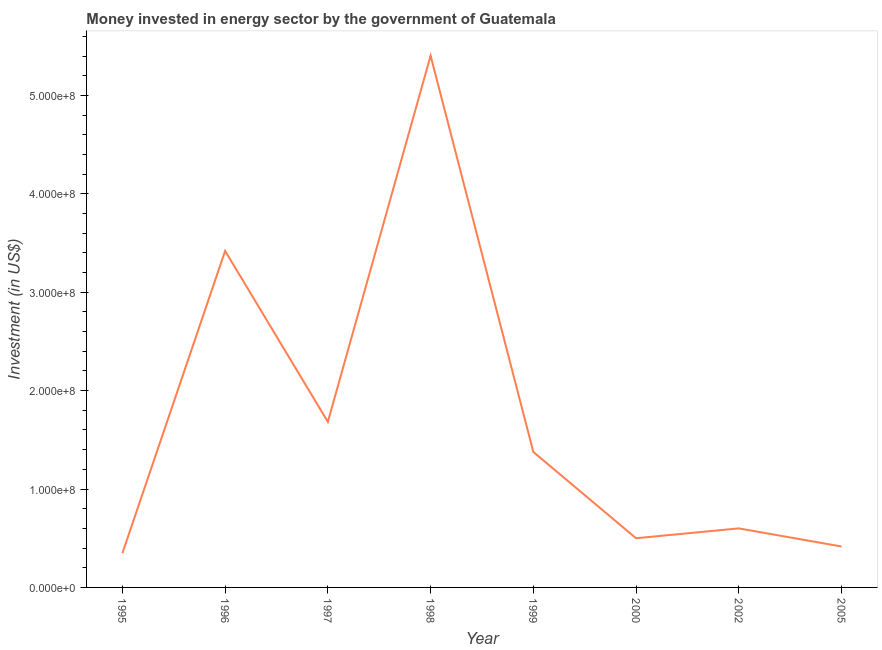What is the investment in energy in 1995?
Ensure brevity in your answer.  3.48e+07. Across all years, what is the maximum investment in energy?
Give a very brief answer. 5.40e+08. Across all years, what is the minimum investment in energy?
Give a very brief answer. 3.48e+07. In which year was the investment in energy minimum?
Give a very brief answer. 1995. What is the sum of the investment in energy?
Provide a succinct answer. 1.37e+09. What is the difference between the investment in energy in 1998 and 2002?
Give a very brief answer. 4.80e+08. What is the average investment in energy per year?
Keep it short and to the point. 1.72e+08. What is the median investment in energy?
Offer a terse response. 9.88e+07. In how many years, is the investment in energy greater than 360000000 US$?
Keep it short and to the point. 1. What is the ratio of the investment in energy in 1995 to that in 2000?
Give a very brief answer. 0.7. Is the difference between the investment in energy in 2002 and 2005 greater than the difference between any two years?
Provide a short and direct response. No. What is the difference between the highest and the second highest investment in energy?
Ensure brevity in your answer.  1.98e+08. What is the difference between the highest and the lowest investment in energy?
Your response must be concise. 5.06e+08. Does the investment in energy monotonically increase over the years?
Provide a short and direct response. No. How many years are there in the graph?
Give a very brief answer. 8. Does the graph contain any zero values?
Offer a terse response. No. Does the graph contain grids?
Your answer should be very brief. No. What is the title of the graph?
Provide a short and direct response. Money invested in energy sector by the government of Guatemala. What is the label or title of the Y-axis?
Ensure brevity in your answer.  Investment (in US$). What is the Investment (in US$) of 1995?
Provide a succinct answer. 3.48e+07. What is the Investment (in US$) in 1996?
Your response must be concise. 3.42e+08. What is the Investment (in US$) in 1997?
Give a very brief answer. 1.68e+08. What is the Investment (in US$) in 1998?
Your answer should be compact. 5.40e+08. What is the Investment (in US$) in 1999?
Provide a short and direct response. 1.38e+08. What is the Investment (in US$) in 2002?
Your answer should be compact. 6.00e+07. What is the Investment (in US$) in 2005?
Give a very brief answer. 4.16e+07. What is the difference between the Investment (in US$) in 1995 and 1996?
Your answer should be compact. -3.07e+08. What is the difference between the Investment (in US$) in 1995 and 1997?
Your answer should be compact. -1.34e+08. What is the difference between the Investment (in US$) in 1995 and 1998?
Provide a succinct answer. -5.06e+08. What is the difference between the Investment (in US$) in 1995 and 1999?
Provide a succinct answer. -1.03e+08. What is the difference between the Investment (in US$) in 1995 and 2000?
Offer a very short reply. -1.52e+07. What is the difference between the Investment (in US$) in 1995 and 2002?
Your answer should be very brief. -2.52e+07. What is the difference between the Investment (in US$) in 1995 and 2005?
Offer a terse response. -6.80e+06. What is the difference between the Investment (in US$) in 1996 and 1997?
Provide a short and direct response. 1.74e+08. What is the difference between the Investment (in US$) in 1996 and 1998?
Give a very brief answer. -1.98e+08. What is the difference between the Investment (in US$) in 1996 and 1999?
Give a very brief answer. 2.04e+08. What is the difference between the Investment (in US$) in 1996 and 2000?
Offer a terse response. 2.92e+08. What is the difference between the Investment (in US$) in 1996 and 2002?
Offer a terse response. 2.82e+08. What is the difference between the Investment (in US$) in 1996 and 2005?
Offer a very short reply. 3.00e+08. What is the difference between the Investment (in US$) in 1997 and 1998?
Your answer should be compact. -3.72e+08. What is the difference between the Investment (in US$) in 1997 and 1999?
Offer a terse response. 3.06e+07. What is the difference between the Investment (in US$) in 1997 and 2000?
Provide a short and direct response. 1.18e+08. What is the difference between the Investment (in US$) in 1997 and 2002?
Offer a very short reply. 1.08e+08. What is the difference between the Investment (in US$) in 1997 and 2005?
Keep it short and to the point. 1.27e+08. What is the difference between the Investment (in US$) in 1998 and 1999?
Provide a succinct answer. 4.03e+08. What is the difference between the Investment (in US$) in 1998 and 2000?
Provide a succinct answer. 4.90e+08. What is the difference between the Investment (in US$) in 1998 and 2002?
Offer a very short reply. 4.80e+08. What is the difference between the Investment (in US$) in 1998 and 2005?
Give a very brief answer. 4.99e+08. What is the difference between the Investment (in US$) in 1999 and 2000?
Provide a short and direct response. 8.77e+07. What is the difference between the Investment (in US$) in 1999 and 2002?
Provide a succinct answer. 7.77e+07. What is the difference between the Investment (in US$) in 1999 and 2005?
Make the answer very short. 9.61e+07. What is the difference between the Investment (in US$) in 2000 and 2002?
Your response must be concise. -1.00e+07. What is the difference between the Investment (in US$) in 2000 and 2005?
Offer a very short reply. 8.40e+06. What is the difference between the Investment (in US$) in 2002 and 2005?
Provide a succinct answer. 1.84e+07. What is the ratio of the Investment (in US$) in 1995 to that in 1996?
Provide a succinct answer. 0.1. What is the ratio of the Investment (in US$) in 1995 to that in 1997?
Give a very brief answer. 0.21. What is the ratio of the Investment (in US$) in 1995 to that in 1998?
Offer a very short reply. 0.06. What is the ratio of the Investment (in US$) in 1995 to that in 1999?
Provide a succinct answer. 0.25. What is the ratio of the Investment (in US$) in 1995 to that in 2000?
Ensure brevity in your answer.  0.7. What is the ratio of the Investment (in US$) in 1995 to that in 2002?
Your answer should be compact. 0.58. What is the ratio of the Investment (in US$) in 1995 to that in 2005?
Provide a short and direct response. 0.84. What is the ratio of the Investment (in US$) in 1996 to that in 1997?
Provide a short and direct response. 2.03. What is the ratio of the Investment (in US$) in 1996 to that in 1998?
Offer a terse response. 0.63. What is the ratio of the Investment (in US$) in 1996 to that in 1999?
Provide a short and direct response. 2.48. What is the ratio of the Investment (in US$) in 1996 to that in 2000?
Keep it short and to the point. 6.84. What is the ratio of the Investment (in US$) in 1996 to that in 2002?
Make the answer very short. 5.7. What is the ratio of the Investment (in US$) in 1996 to that in 2005?
Provide a short and direct response. 8.22. What is the ratio of the Investment (in US$) in 1997 to that in 1998?
Keep it short and to the point. 0.31. What is the ratio of the Investment (in US$) in 1997 to that in 1999?
Keep it short and to the point. 1.22. What is the ratio of the Investment (in US$) in 1997 to that in 2000?
Offer a very short reply. 3.37. What is the ratio of the Investment (in US$) in 1997 to that in 2002?
Your answer should be compact. 2.81. What is the ratio of the Investment (in US$) in 1997 to that in 2005?
Make the answer very short. 4.05. What is the ratio of the Investment (in US$) in 1998 to that in 1999?
Offer a very short reply. 3.92. What is the ratio of the Investment (in US$) in 1998 to that in 2000?
Offer a very short reply. 10.81. What is the ratio of the Investment (in US$) in 1998 to that in 2002?
Ensure brevity in your answer.  9.01. What is the ratio of the Investment (in US$) in 1998 to that in 2005?
Provide a short and direct response. 12.99. What is the ratio of the Investment (in US$) in 1999 to that in 2000?
Your answer should be compact. 2.75. What is the ratio of the Investment (in US$) in 1999 to that in 2002?
Provide a succinct answer. 2.29. What is the ratio of the Investment (in US$) in 1999 to that in 2005?
Provide a short and direct response. 3.31. What is the ratio of the Investment (in US$) in 2000 to that in 2002?
Keep it short and to the point. 0.83. What is the ratio of the Investment (in US$) in 2000 to that in 2005?
Provide a short and direct response. 1.2. What is the ratio of the Investment (in US$) in 2002 to that in 2005?
Provide a succinct answer. 1.44. 